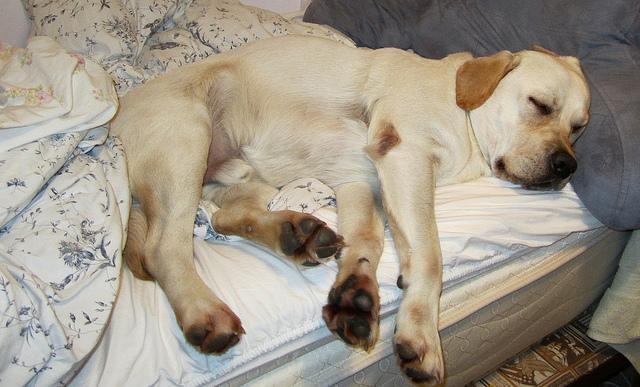How many people carry the surfboard?
Give a very brief answer. 0. 